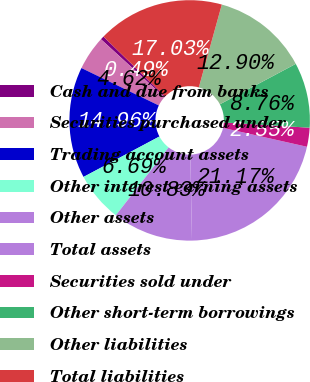Convert chart to OTSL. <chart><loc_0><loc_0><loc_500><loc_500><pie_chart><fcel>Cash and due from banks<fcel>Securities purchased under<fcel>Trading account assets<fcel>Other interest-earning assets<fcel>Other assets<fcel>Total assets<fcel>Securities sold under<fcel>Other short-term borrowings<fcel>Other liabilities<fcel>Total liabilities<nl><fcel>0.49%<fcel>4.62%<fcel>14.96%<fcel>6.69%<fcel>10.83%<fcel>21.17%<fcel>2.55%<fcel>8.76%<fcel>12.9%<fcel>17.03%<nl></chart> 